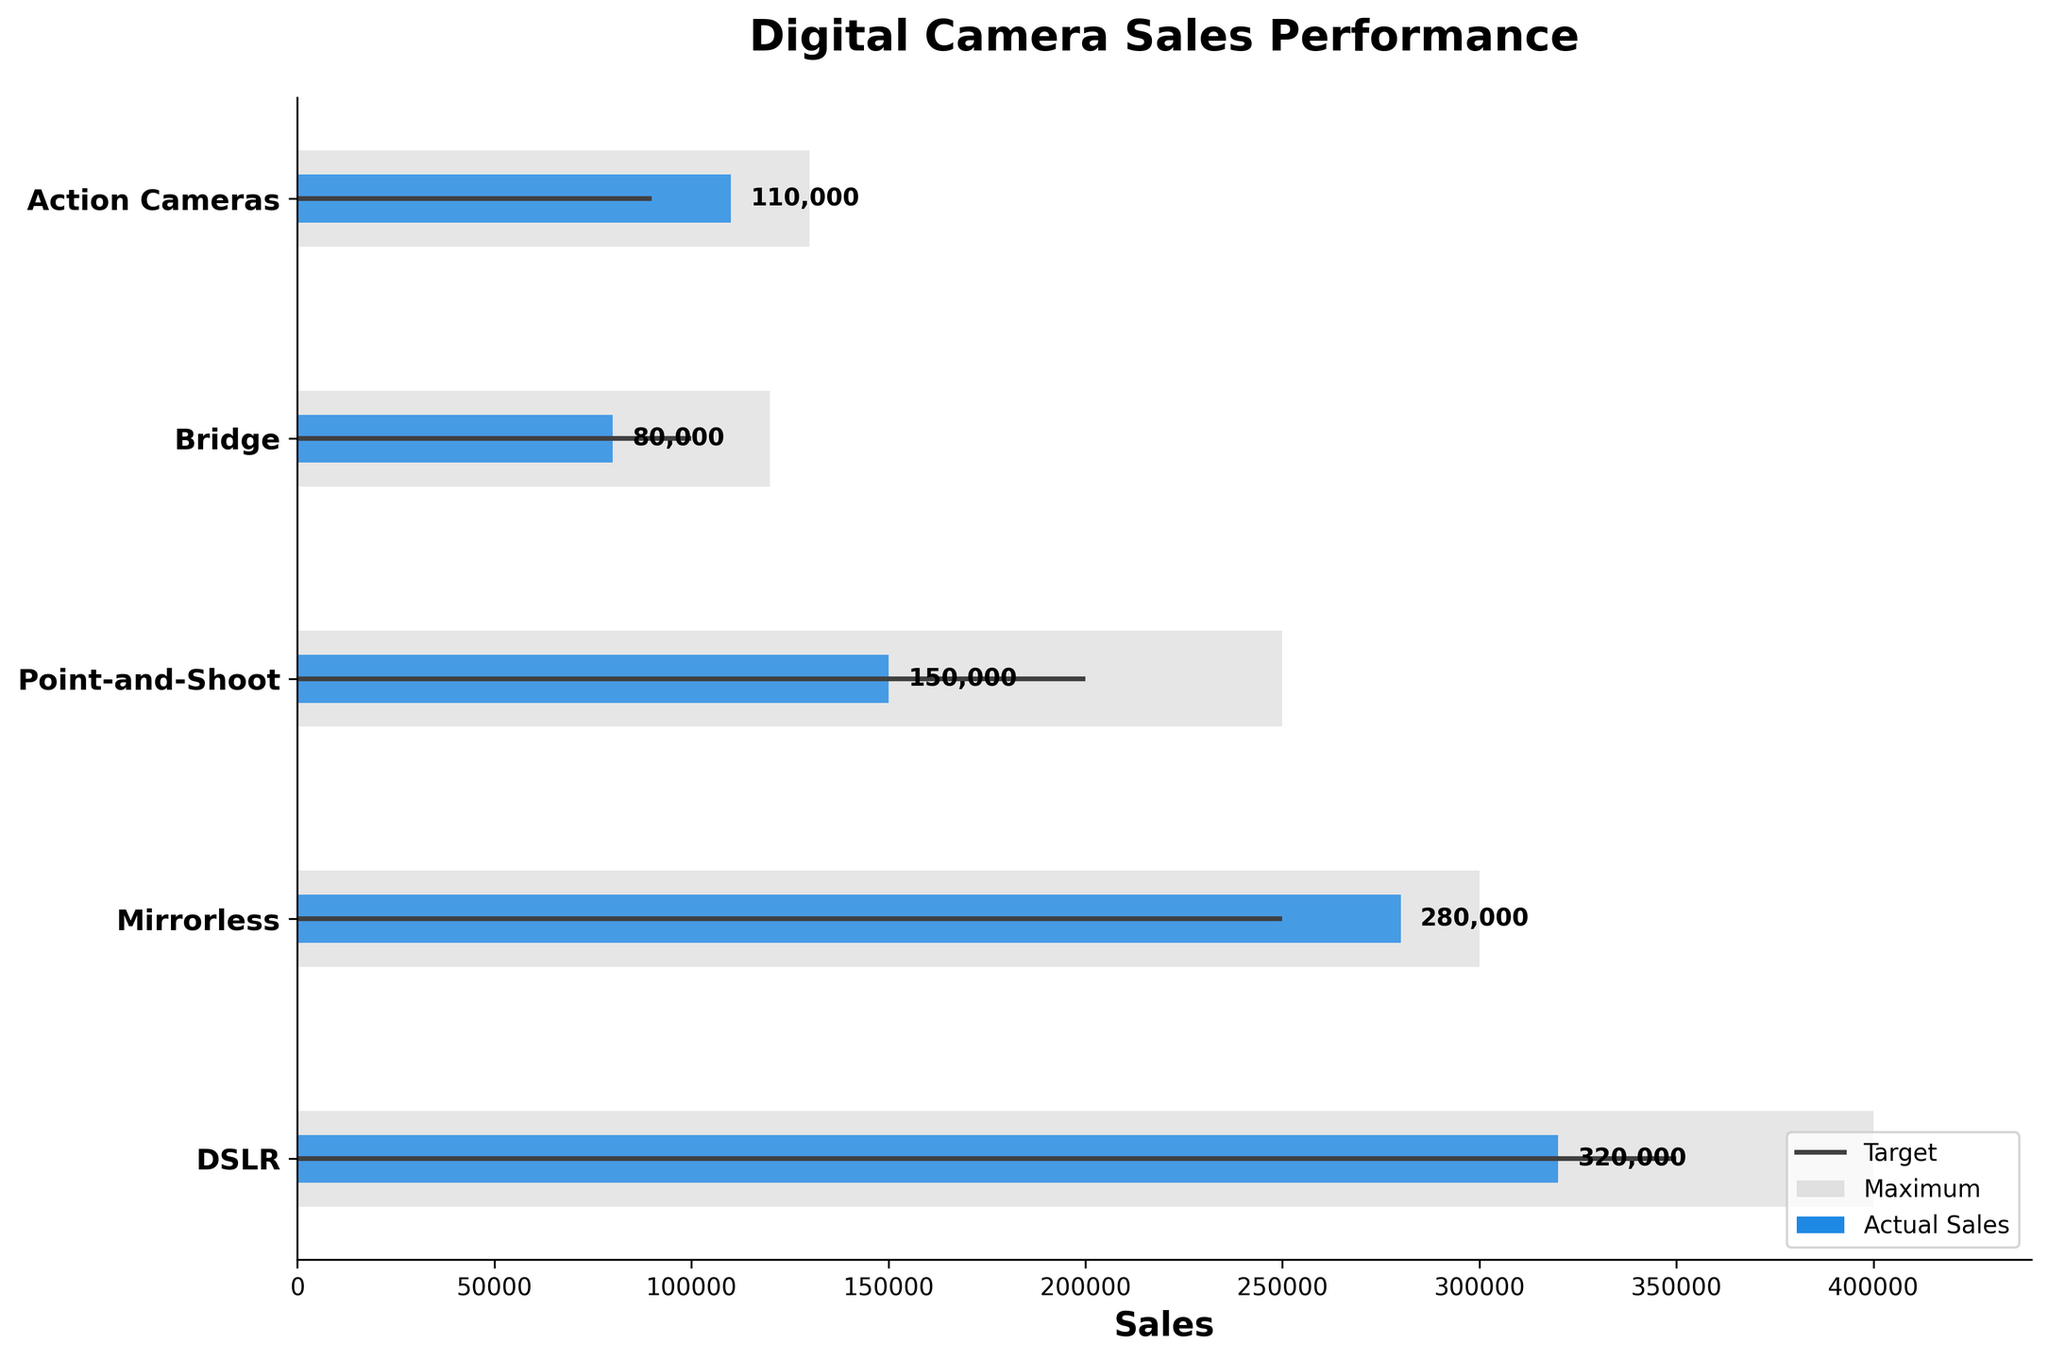what is the title of the figure? The title of the figure is shown at the top, and it indicates the main subject of the chart. It is "Digital Camera Sales Performance."
Answer: Digital Camera Sales Performance Which camera type has the highest actual sales? By comparing the lengths of the blue bars, the DSLR category has the highest actual sales.
Answer: DSLR How far below target were the Point-and-Shoot camera sales? The target for Point-and-Shoot cameras is 200,000, while actual sales are 150,000. The difference is 200,000 - 150,000 = 50,000.
Answer: 50,000 Which camera type's actual sales exceed its target? Compare the blue bars (actual sales) with the gray lines (targets). Only Mirrorless and Action Cameras have actual sales exceeding their targets.
Answer: Mirrorless, Action Cameras What is the range of maximum sales values across all camera types? The minimum maximum value is for Bridge cameras at 120,000, and the maximum maximum value is for DSLR cameras at 400,000. The range is 400,000 - 120,000 = 280,000.
Answer: 280,000 What percentage of the target was reached by Action Cameras? The target for Action Cameras is 90,000, and actual sales are 110,000. The percentage is (110,000/90,000) * 100 ≈ 122.22%.
Answer: 122.22% How do the actual sales of Mirrorless cameras compare to DSLR cameras in terms of percentage? The actual sales for Mirrorless cameras are 280,000, and for DSLR cameras, it's 320,000. The percentage is (280,000/320,000) * 100 ≈ 87.5%.
Answer: 87.5% Which camera type has the smallest difference between actual sales and maximum potential sales? Compare the difference between actual sales and the maximum potential sales for each camera type. DSLR has 400,000 - 320,000 = 80,000; Mirrorless has 300,000 - 280,000 = 20,000; Point-and-Shoot has 250,000 - 150,000 = 100,000; Bridge has 120,000 - 80,000 = 40,000; Action Cameras has 130,000 - 110,000 = 20,000. The smallest difference is for Mirrorless and Action Cameras at 20,000.
Answer: Mirrorless, Action Cameras Which camera type achieved less than half of its maximum sales? By calculating actual sales as a fraction of maximum sales, Point-and-Shoot (150,000/250,000 = 0.6), Bridge (80,000/120,000 = 0.67), and Action Cameras (110,000/130,000 = 0.85) all exceeded 0.5, but Mirrorless and DSLR also exceeded half. Hence, none of the camera types achieved less than half of their maximum sales.
Answer: None 